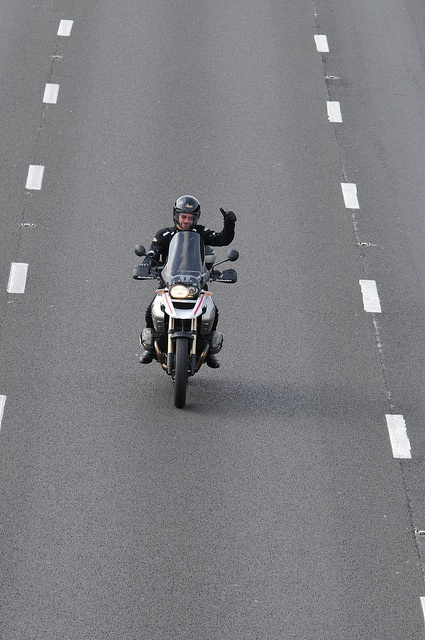Describe the objects in this image and their specific colors. I can see motorcycle in gray, black, darkgray, and white tones and people in gray and black tones in this image. 